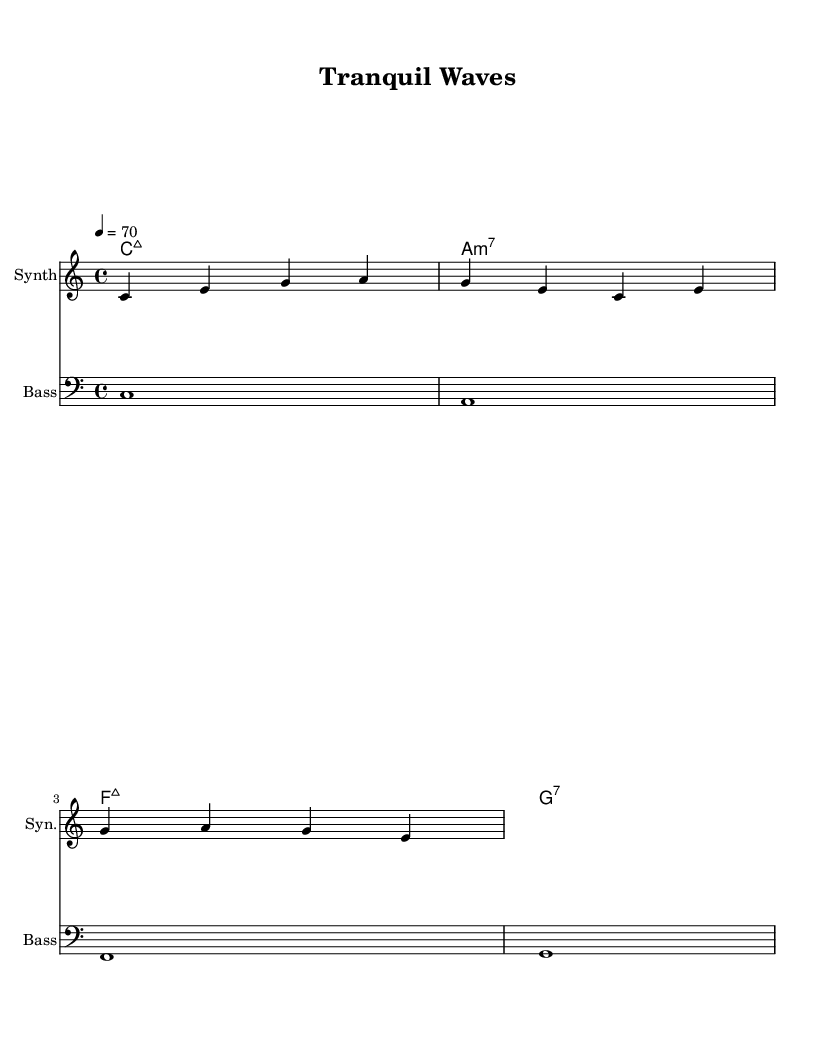What is the key signature of this music? The key signature is indicated at the beginning of the staff, showing no sharps or flats, which corresponds to C major.
Answer: C major What is the time signature of this piece? The time signature is located at the beginning of the staff, shown as a "4/4", meaning there are four beats per measure with a quarter note receiving one beat.
Answer: 4/4 What is the tempo marking for this music? The tempo marking, indicated in the score, is "4 = 70", which signifies that there are 70 beats per minute, with each beat represented by a quarter note.
Answer: 70 How many measures are in the melody? Counting the notes and measuring from the provided staff, there are two complete measures, each containing four beats.
Answer: 2 What type of chord is used at the beginning of the harmony? The first chord labeled in the harmony section shows "C:maj7", indicating it is a C major 7th chord.
Answer: C:maj7 Is this music primarily for solo instruments or ensemble? The score indicates multiple staves, one for the synth and one for bass, suggesting it's written for an ensemble rather than a single solo instrument.
Answer: Ensemble 